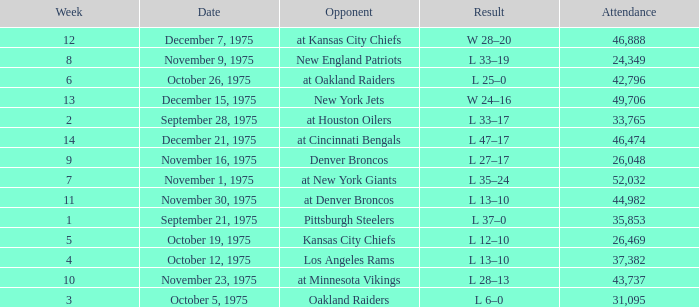What is the lowest Week when the result was l 6–0? 3.0. 